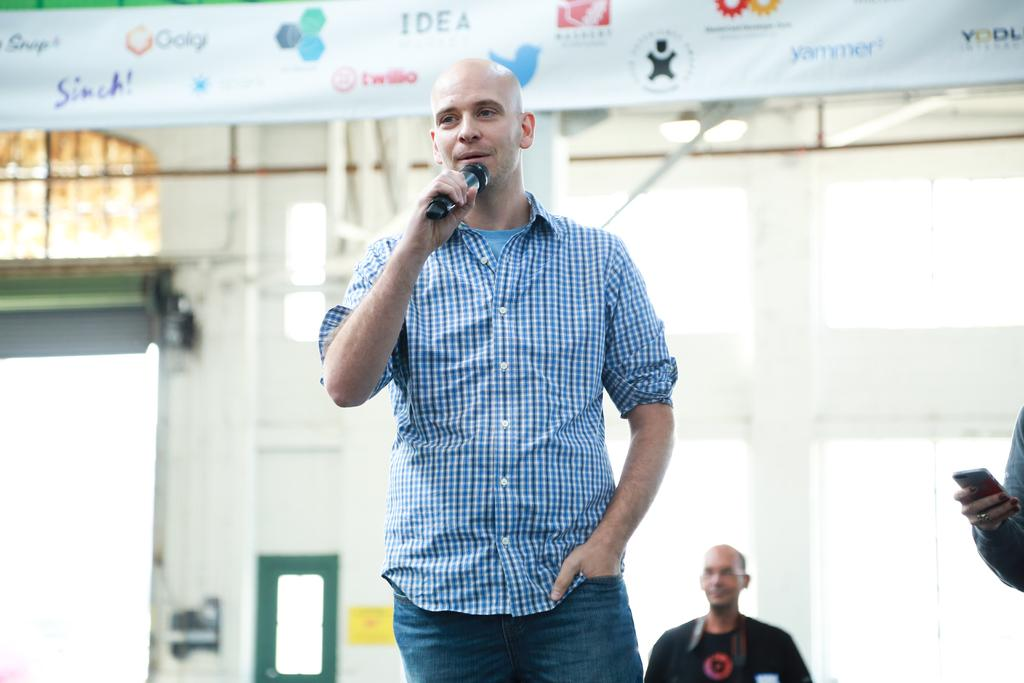What is the man in the image doing? The man is talking on a microphone. What can be seen in the background of the image? There is a wall and a banner in the background of the image. What is the man wearing on his face? The man is wearing spectacles. What type of toys can be seen on the floor near the man? There are no toys present in the image. What color is the robin perched on the man's shoulder? There is no robin present in the image. 